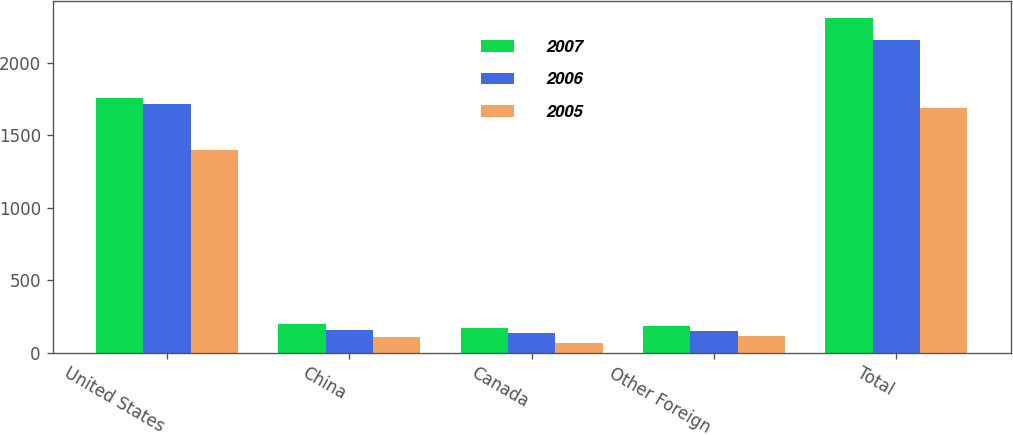Convert chart. <chart><loc_0><loc_0><loc_500><loc_500><stacked_bar_chart><ecel><fcel>United States<fcel>China<fcel>Canada<fcel>Other Foreign<fcel>Total<nl><fcel>2007<fcel>1757<fcel>197.6<fcel>171.9<fcel>185.6<fcel>2312.1<nl><fcel>2006<fcel>1720.9<fcel>154.2<fcel>137.3<fcel>148.9<fcel>2161.3<nl><fcel>2005<fcel>1400.6<fcel>106.8<fcel>64.5<fcel>117.3<fcel>1689.2<nl></chart> 